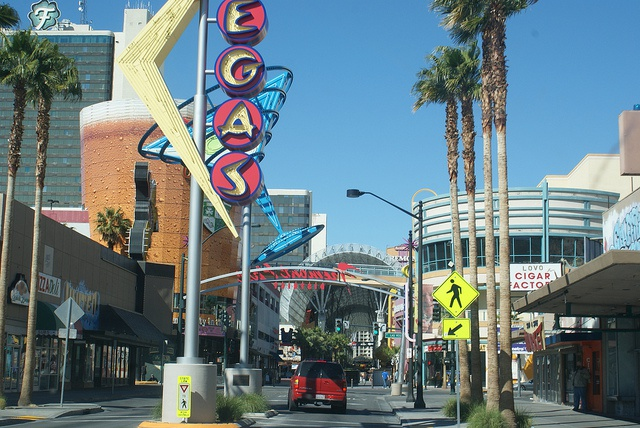Describe the objects in this image and their specific colors. I can see car in teal, black, brown, maroon, and gray tones, people in teal, black, purple, navy, and gray tones, car in teal, gray, blue, and black tones, traffic light in teal, black, and gray tones, and traffic light in teal and black tones in this image. 